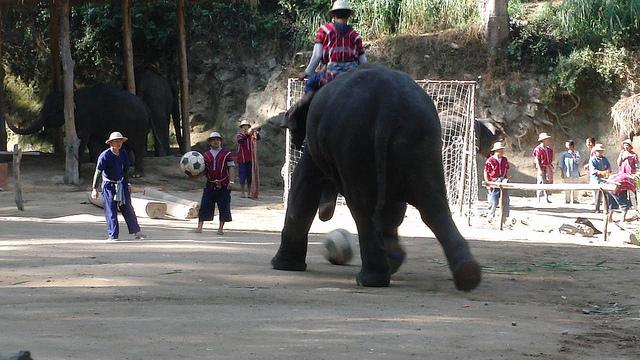What is this this elephant doing? Please explain your reasoning. playing soccer. This elephant is not eating or drinking, nor is he painting.  he is playing with a ball. 